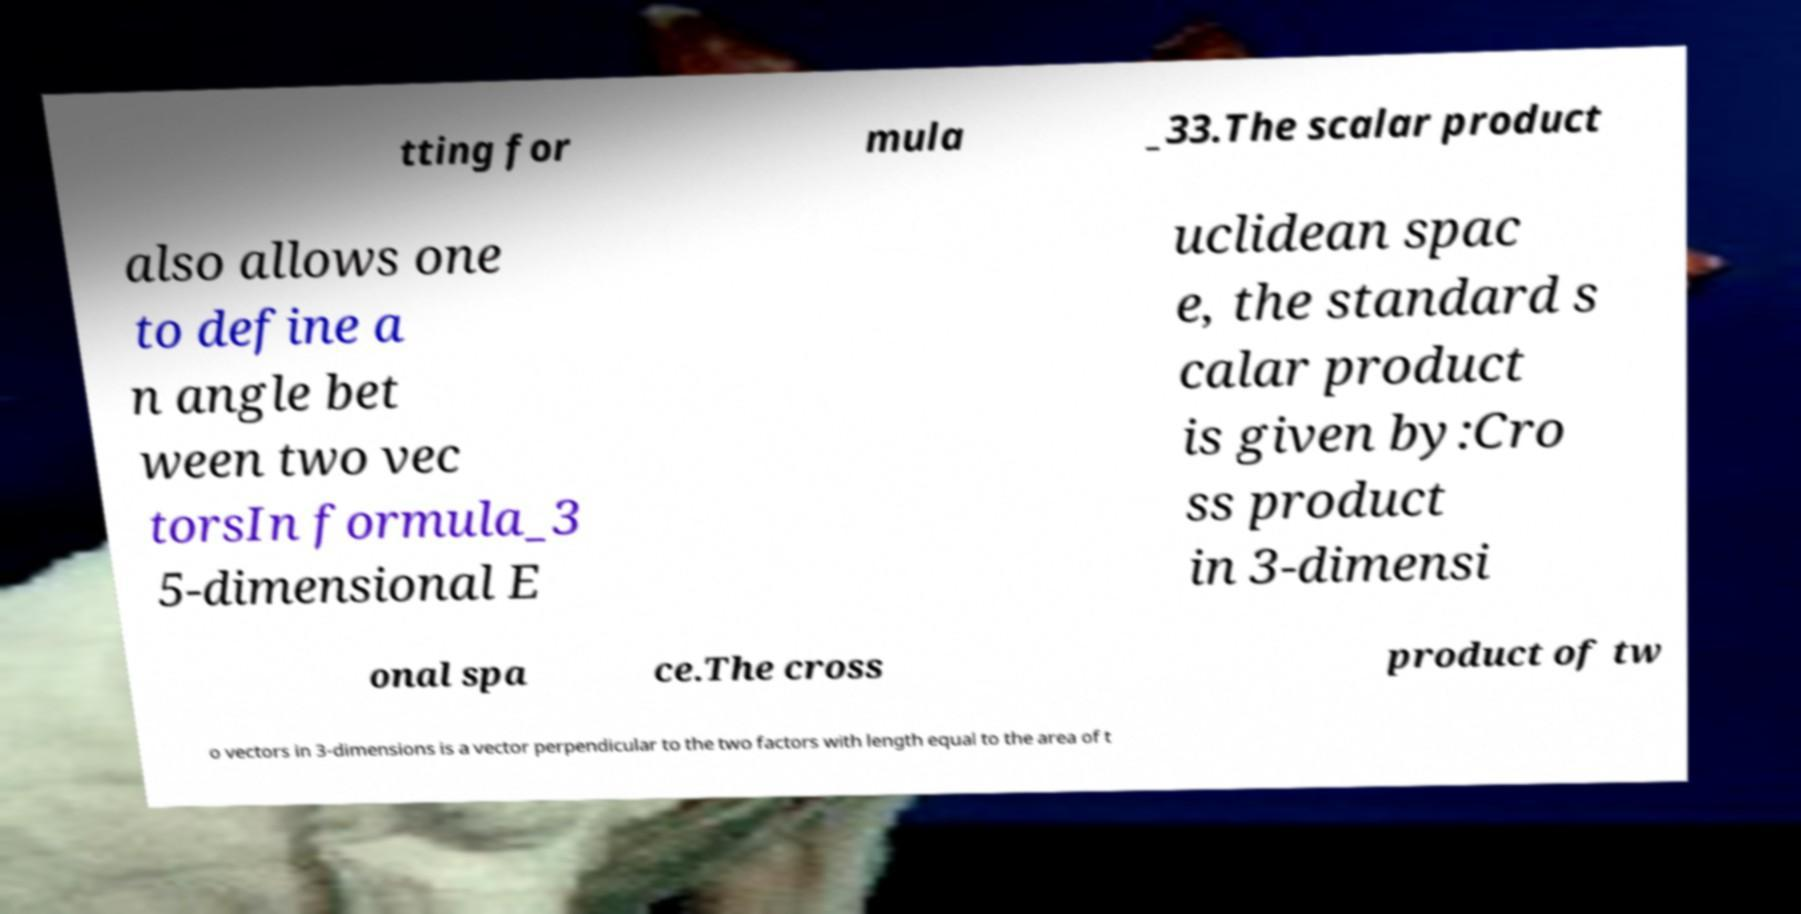Please read and relay the text visible in this image. What does it say? tting for mula _33.The scalar product also allows one to define a n angle bet ween two vec torsIn formula_3 5-dimensional E uclidean spac e, the standard s calar product is given by:Cro ss product in 3-dimensi onal spa ce.The cross product of tw o vectors in 3-dimensions is a vector perpendicular to the two factors with length equal to the area of t 